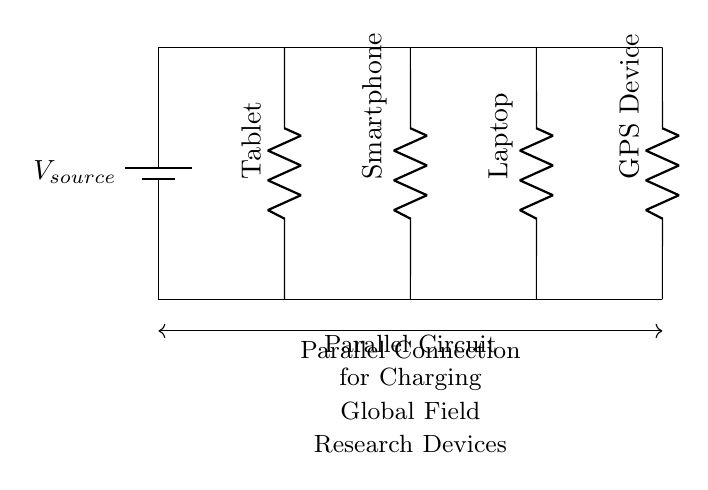What type of circuit is depicted? The circuit is a parallel circuit, which is indicated by multiple paths connecting the components directly to the voltage source.
Answer: Parallel circuit How many devices are connected in this circuit? There are four devices: a tablet, smartphone, laptop, and GPS device, each represented as a resistor in the circuit diagram.
Answer: Four What is the role of the voltage source in this circuit? The voltage source provides the necessary electrical potential for all connected devices. In a parallel circuit, each device receives the same voltage from the source.
Answer: Supply voltage Which device is located at the first position? The first device (from the left) is a tablet, as shown by the labeling in the diagram.
Answer: Tablet What is a key advantage of this parallel configuration for charging devices? A key advantage is that each device can be charged simultaneously without affecting the charging voltage across each one, allowing for faster and efficient charging.
Answer: Simultaneous charging What will happen if one device is disconnected while others are charging? If one device is disconnected, the remaining devices will continue to receive the same voltage from the source, as the circuit is designed to allow independent operation of each branch.
Answer: Other devices remain operational 